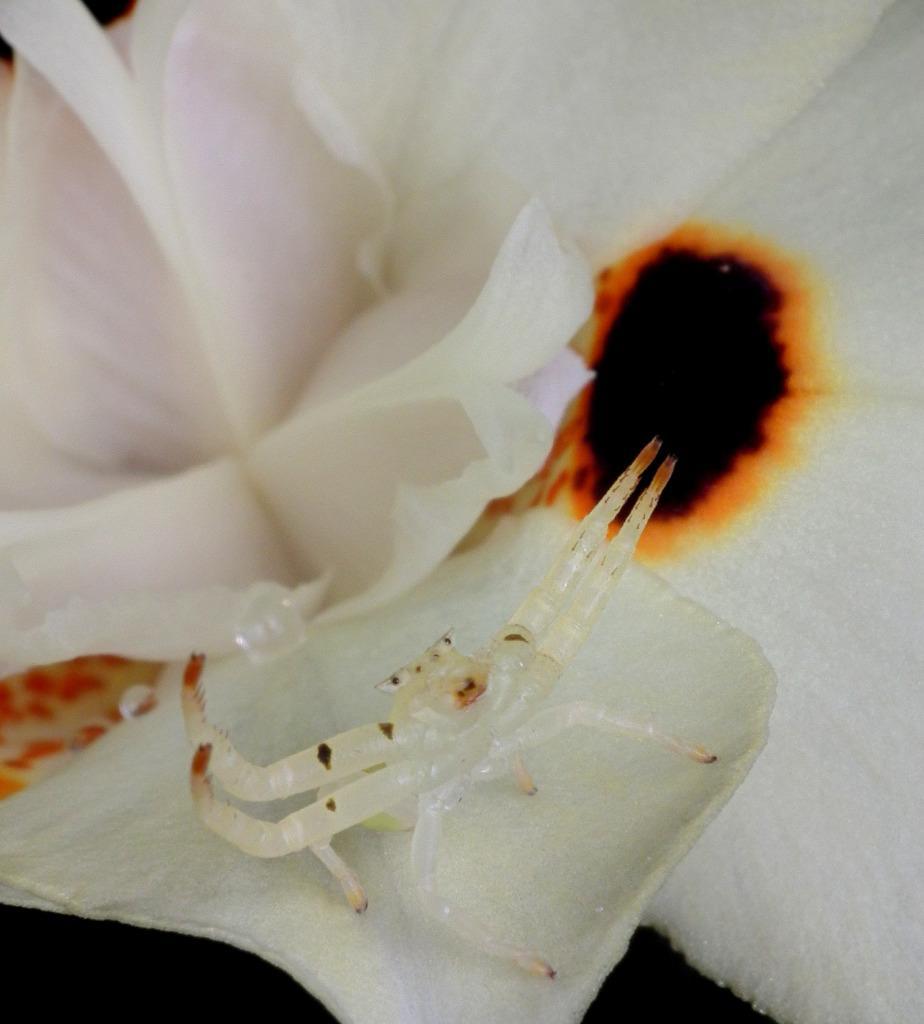Can you describe this image briefly? In this picture we can see an insect, flowers and in the background it is dark. 